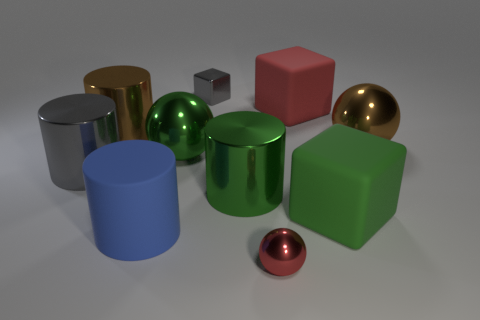Subtract all blocks. How many objects are left? 7 Subtract 0 purple spheres. How many objects are left? 10 Subtract all brown objects. Subtract all big cubes. How many objects are left? 6 Add 3 small red balls. How many small red balls are left? 4 Add 3 yellow metallic cylinders. How many yellow metallic cylinders exist? 3 